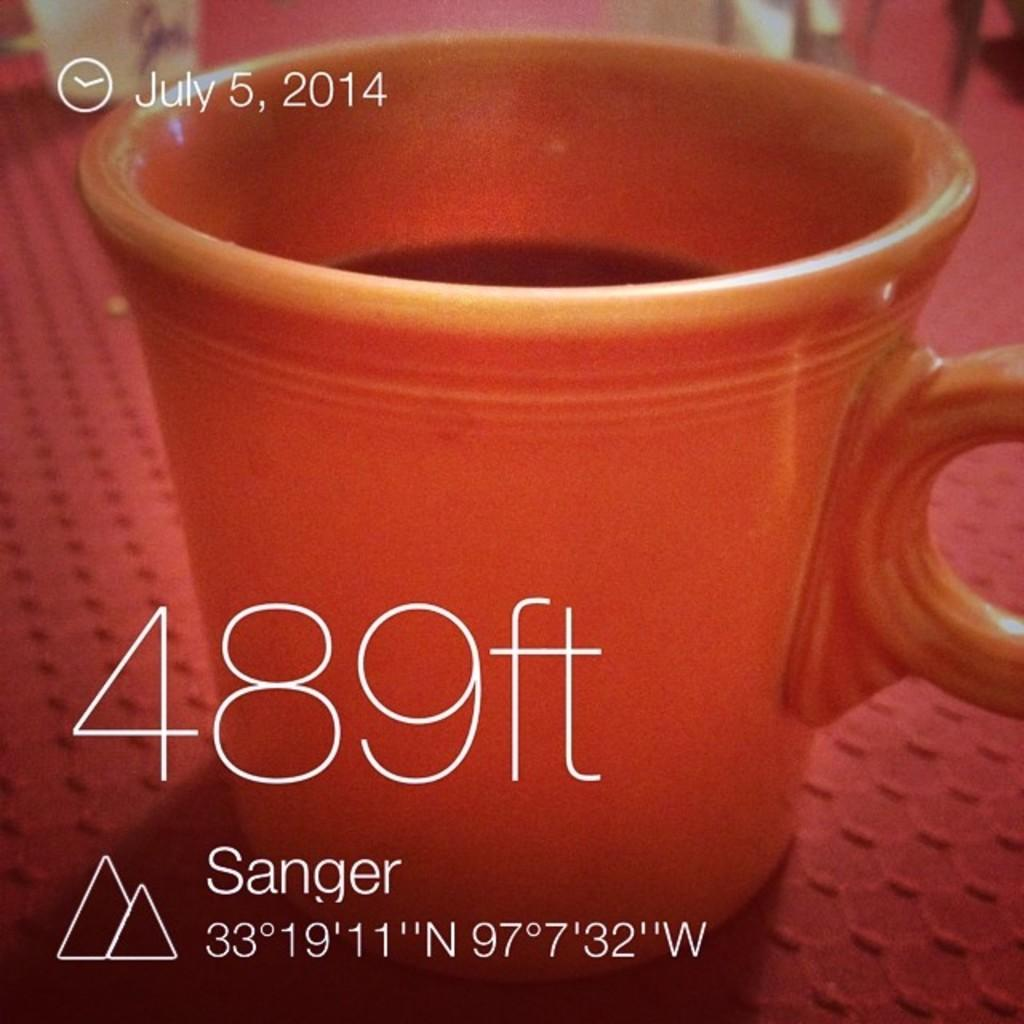<image>
Render a clear and concise summary of the photo. a cup with 489 ft written next to it 